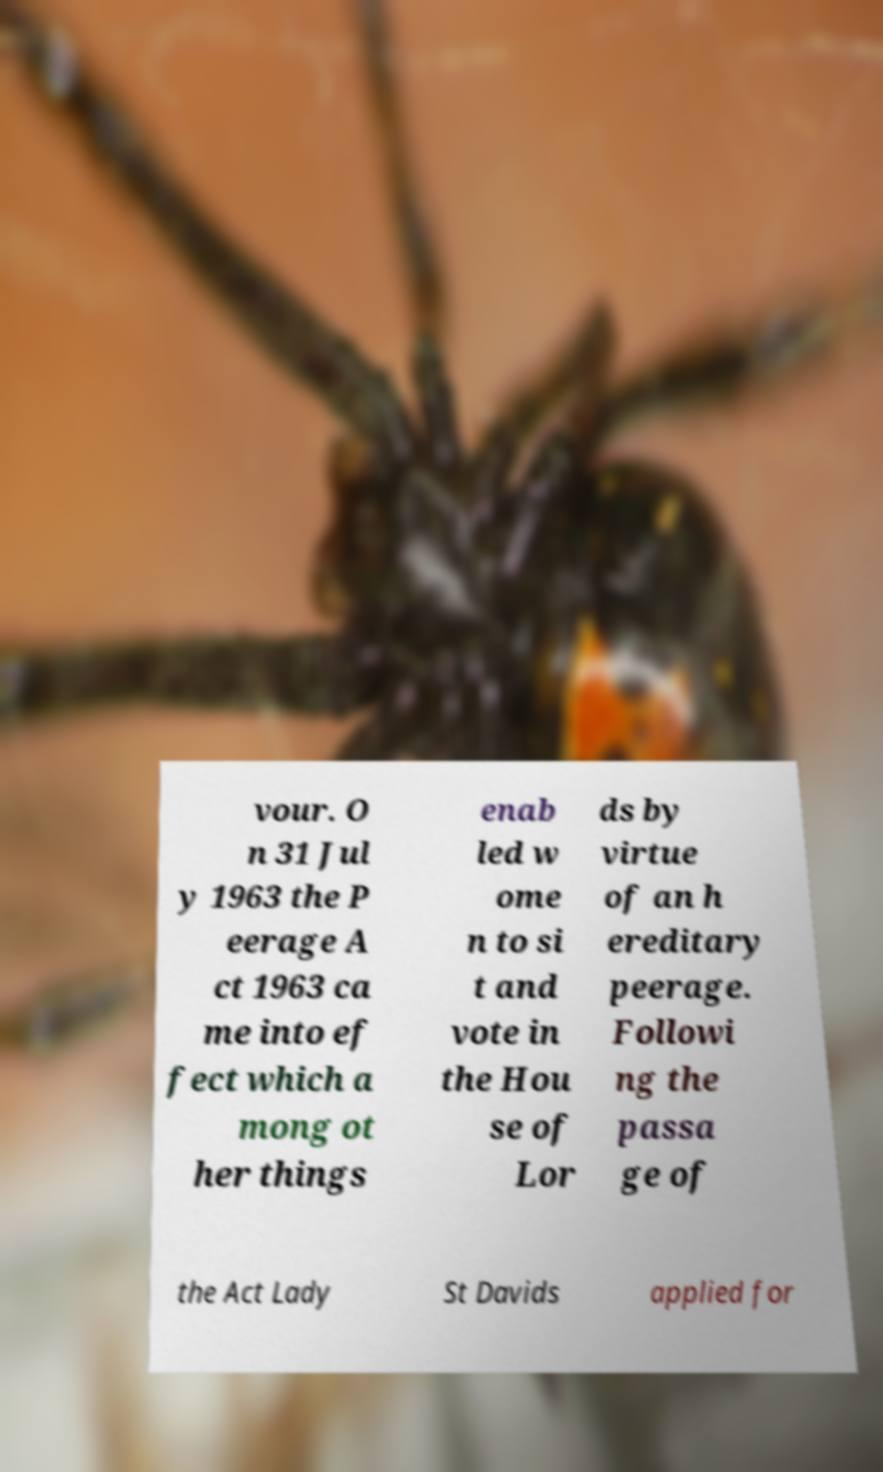Please read and relay the text visible in this image. What does it say? vour. O n 31 Jul y 1963 the P eerage A ct 1963 ca me into ef fect which a mong ot her things enab led w ome n to si t and vote in the Hou se of Lor ds by virtue of an h ereditary peerage. Followi ng the passa ge of the Act Lady St Davids applied for 